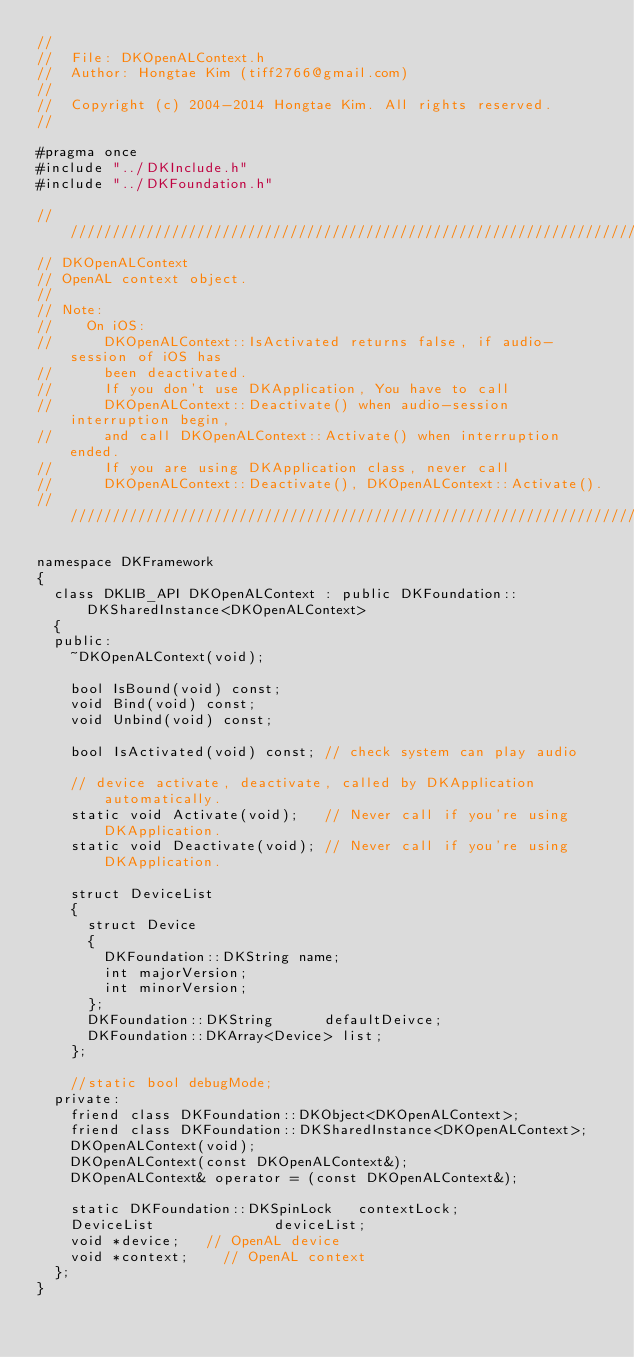<code> <loc_0><loc_0><loc_500><loc_500><_C_>//
//  File: DKOpenALContext.h
//  Author: Hongtae Kim (tiff2766@gmail.com)
//
//  Copyright (c) 2004-2014 Hongtae Kim. All rights reserved.
//

#pragma once
#include "../DKInclude.h"
#include "../DKFoundation.h"

////////////////////////////////////////////////////////////////////////////////
// DKOpenALContext
// OpenAL context object.
//
// Note:
//    On iOS:
//      DKOpenALContext::IsActivated returns false, if audio-session of iOS has
//      been deactivated.
//      If you don't use DKApplication, You have to call
//      DKOpenALContext::Deactivate() when audio-session interruption begin,
//      and call DKOpenALContext::Activate() when interruption ended.
//      If you are using DKApplication class, never call
//      DKOpenALContext::Deactivate(), DKOpenALContext::Activate().
////////////////////////////////////////////////////////////////////////////////

namespace DKFramework
{
	class DKLIB_API DKOpenALContext : public DKFoundation::DKSharedInstance<DKOpenALContext>
	{
	public:
		~DKOpenALContext(void);

		bool IsBound(void) const;
		void Bind(void) const;
		void Unbind(void) const;

		bool IsActivated(void) const; // check system can play audio

		// device activate, deactivate, called by DKApplication automatically.
		static void Activate(void);   // Never call if you're using DKApplication.
		static void Deactivate(void); // Never call if you're using DKApplication.

		struct DeviceList
		{
			struct Device
			{
				DKFoundation::DKString name;
				int majorVersion;
				int minorVersion;
			};
			DKFoundation::DKString			defaultDeivce;
			DKFoundation::DKArray<Device>	list;
		};

		//static bool debugMode;
	private:
		friend class DKFoundation::DKObject<DKOpenALContext>;
		friend class DKFoundation::DKSharedInstance<DKOpenALContext>;
		DKOpenALContext(void);
		DKOpenALContext(const DKOpenALContext&);
		DKOpenALContext& operator = (const DKOpenALContext&);

		static DKFoundation::DKSpinLock		contextLock;
		DeviceList							deviceList;
		void *device;		// OpenAL device
		void *context;		// OpenAL context
	};
}
</code> 